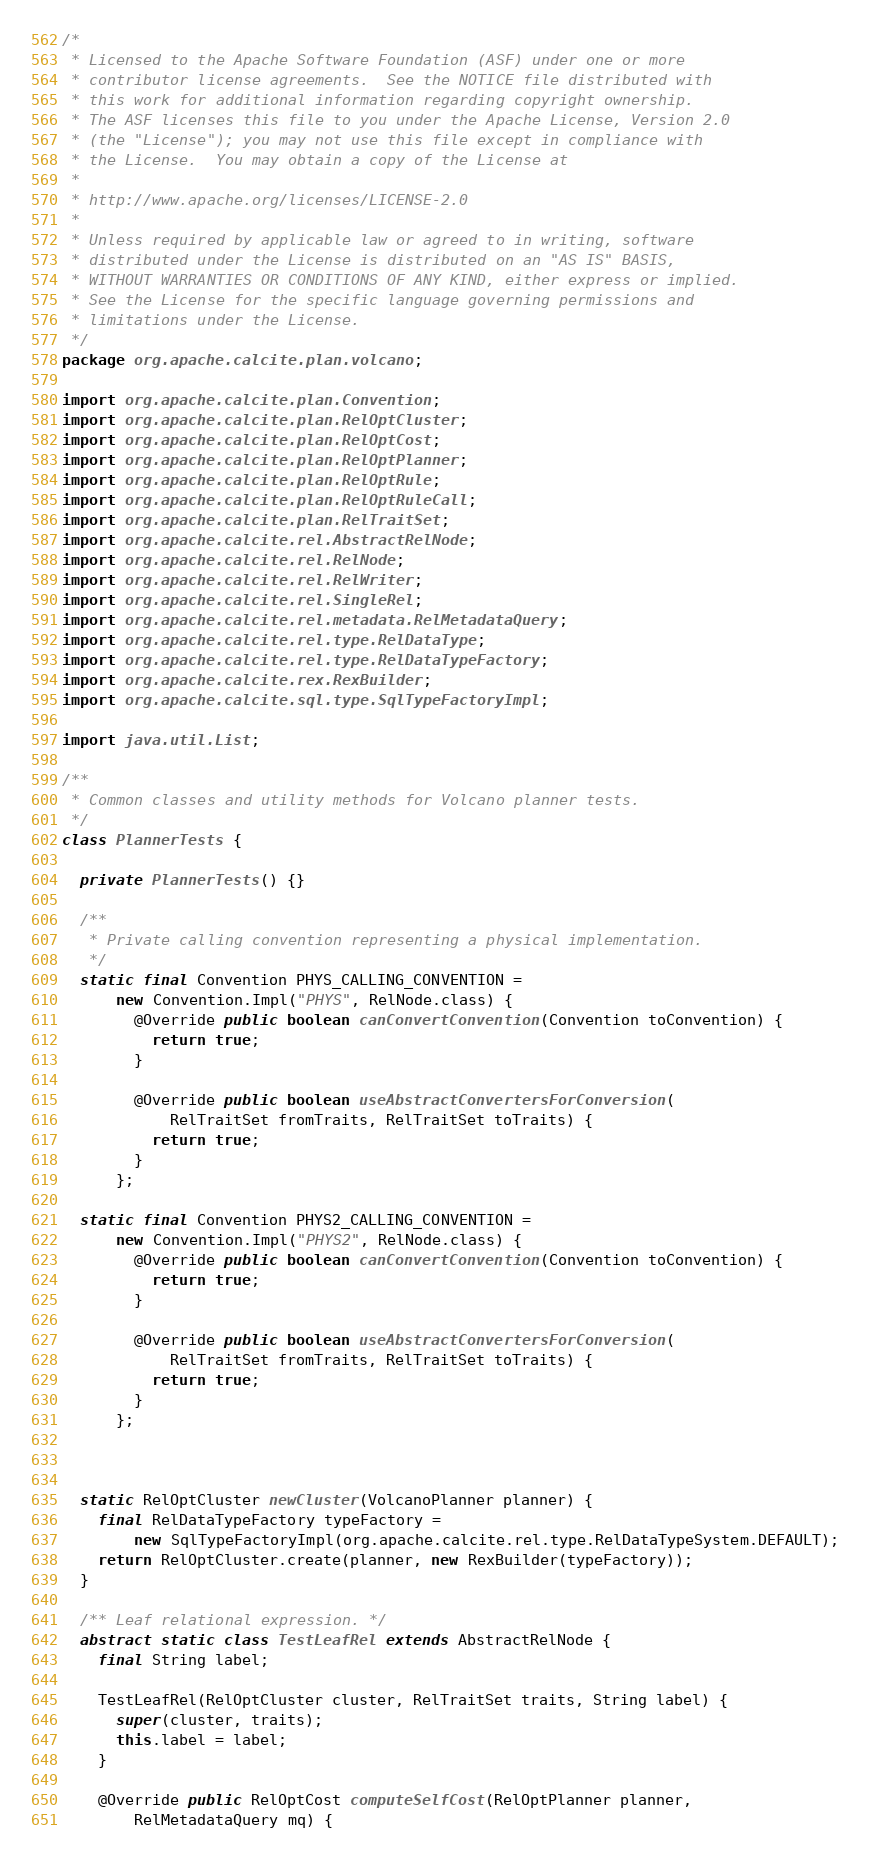<code> <loc_0><loc_0><loc_500><loc_500><_Java_>/*
 * Licensed to the Apache Software Foundation (ASF) under one or more
 * contributor license agreements.  See the NOTICE file distributed with
 * this work for additional information regarding copyright ownership.
 * The ASF licenses this file to you under the Apache License, Version 2.0
 * (the "License"); you may not use this file except in compliance with
 * the License.  You may obtain a copy of the License at
 *
 * http://www.apache.org/licenses/LICENSE-2.0
 *
 * Unless required by applicable law or agreed to in writing, software
 * distributed under the License is distributed on an "AS IS" BASIS,
 * WITHOUT WARRANTIES OR CONDITIONS OF ANY KIND, either express or implied.
 * See the License for the specific language governing permissions and
 * limitations under the License.
 */
package org.apache.calcite.plan.volcano;

import org.apache.calcite.plan.Convention;
import org.apache.calcite.plan.RelOptCluster;
import org.apache.calcite.plan.RelOptCost;
import org.apache.calcite.plan.RelOptPlanner;
import org.apache.calcite.plan.RelOptRule;
import org.apache.calcite.plan.RelOptRuleCall;
import org.apache.calcite.plan.RelTraitSet;
import org.apache.calcite.rel.AbstractRelNode;
import org.apache.calcite.rel.RelNode;
import org.apache.calcite.rel.RelWriter;
import org.apache.calcite.rel.SingleRel;
import org.apache.calcite.rel.metadata.RelMetadataQuery;
import org.apache.calcite.rel.type.RelDataType;
import org.apache.calcite.rel.type.RelDataTypeFactory;
import org.apache.calcite.rex.RexBuilder;
import org.apache.calcite.sql.type.SqlTypeFactoryImpl;

import java.util.List;

/**
 * Common classes and utility methods for Volcano planner tests.
 */
class PlannerTests {

  private PlannerTests() {}

  /**
   * Private calling convention representing a physical implementation.
   */
  static final Convention PHYS_CALLING_CONVENTION =
      new Convention.Impl("PHYS", RelNode.class) {
        @Override public boolean canConvertConvention(Convention toConvention) {
          return true;
        }

        @Override public boolean useAbstractConvertersForConversion(
            RelTraitSet fromTraits, RelTraitSet toTraits) {
          return true;
        }
      };

  static final Convention PHYS2_CALLING_CONVENTION =
      new Convention.Impl("PHYS2", RelNode.class) {
        @Override public boolean canConvertConvention(Convention toConvention) {
          return true;
        }

        @Override public boolean useAbstractConvertersForConversion(
            RelTraitSet fromTraits, RelTraitSet toTraits) {
          return true;
        }
      };



  static RelOptCluster newCluster(VolcanoPlanner planner) {
    final RelDataTypeFactory typeFactory =
        new SqlTypeFactoryImpl(org.apache.calcite.rel.type.RelDataTypeSystem.DEFAULT);
    return RelOptCluster.create(planner, new RexBuilder(typeFactory));
  }

  /** Leaf relational expression. */
  abstract static class TestLeafRel extends AbstractRelNode {
    final String label;

    TestLeafRel(RelOptCluster cluster, RelTraitSet traits, String label) {
      super(cluster, traits);
      this.label = label;
    }

    @Override public RelOptCost computeSelfCost(RelOptPlanner planner,
        RelMetadataQuery mq) {</code> 